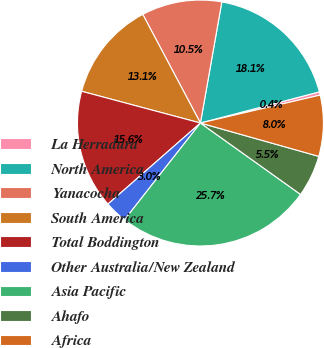Convert chart. <chart><loc_0><loc_0><loc_500><loc_500><pie_chart><fcel>La Herradura<fcel>North America<fcel>Yanacocha<fcel>South America<fcel>Total Boddington<fcel>Other Australia/New Zealand<fcel>Asia Pacific<fcel>Ahafo<fcel>Africa<nl><fcel>0.43%<fcel>18.14%<fcel>10.55%<fcel>13.08%<fcel>15.61%<fcel>2.96%<fcel>25.73%<fcel>5.49%<fcel>8.02%<nl></chart> 